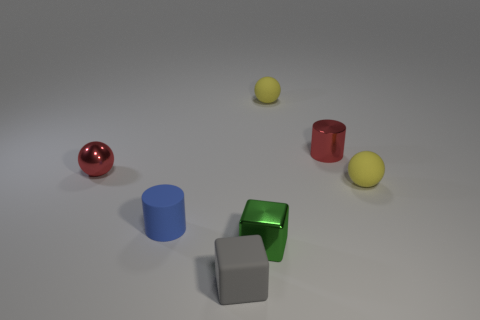What could be the purpose of these objects in the image? These objects might be used for a variety of purposes. They could serve as part of a visual study in color and geometry, be components in a child's building block set, or possibly represent a simplistic digital art piece emphasizing form and shade over detail. Do they seem to be arranged in any particular pattern? There's no obvious pattern to their arrangement. It seems random, possibly to create a visually balanced composition without any explicit symmetry or sequence. 